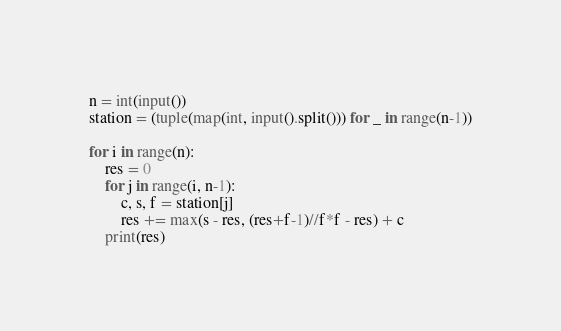<code> <loc_0><loc_0><loc_500><loc_500><_Python_>n = int(input())
station = (tuple(map(int, input().split())) for _ in range(n-1))

for i in range(n):
    res = 0
    for j in range(i, n-1):
        c, s, f = station[j]
        res += max(s - res, (res+f-1)//f*f - res) + c
    print(res)
</code> 